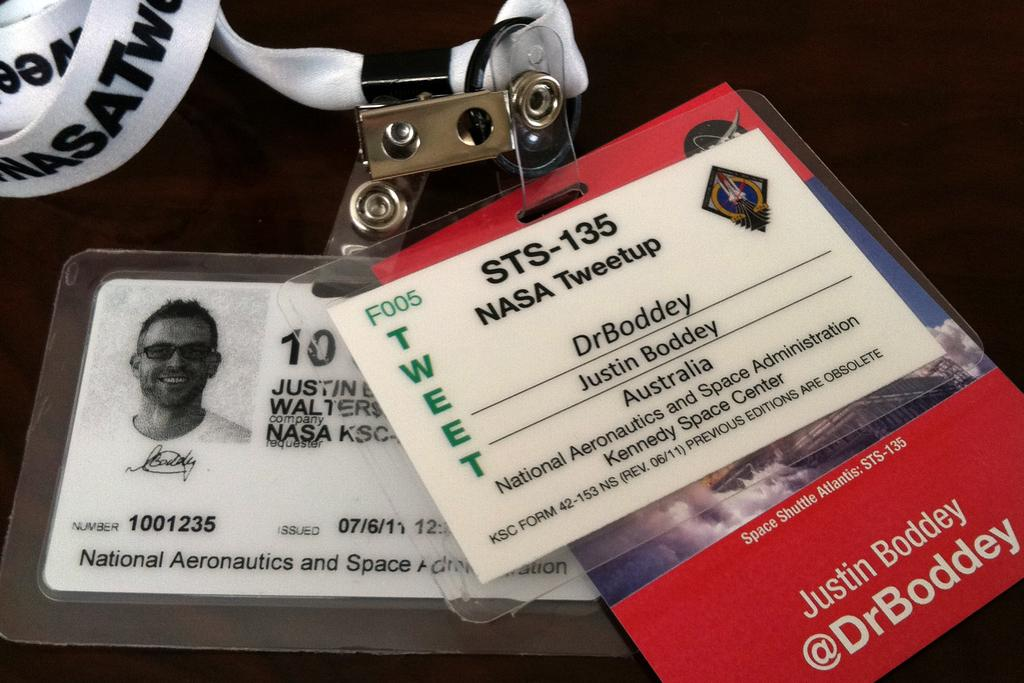What type of objects are in the image? There are ID cards in the image. What can be seen on the ID cards? The ID cards have pictures and text on them. What else is present in the image besides the ID cards? There is a tag and a table in the image. Can you tell me how many horses are in the image? There are no horses present in the image. What does the mom say about the park in the image? There is no mom or park mentioned in the image. 